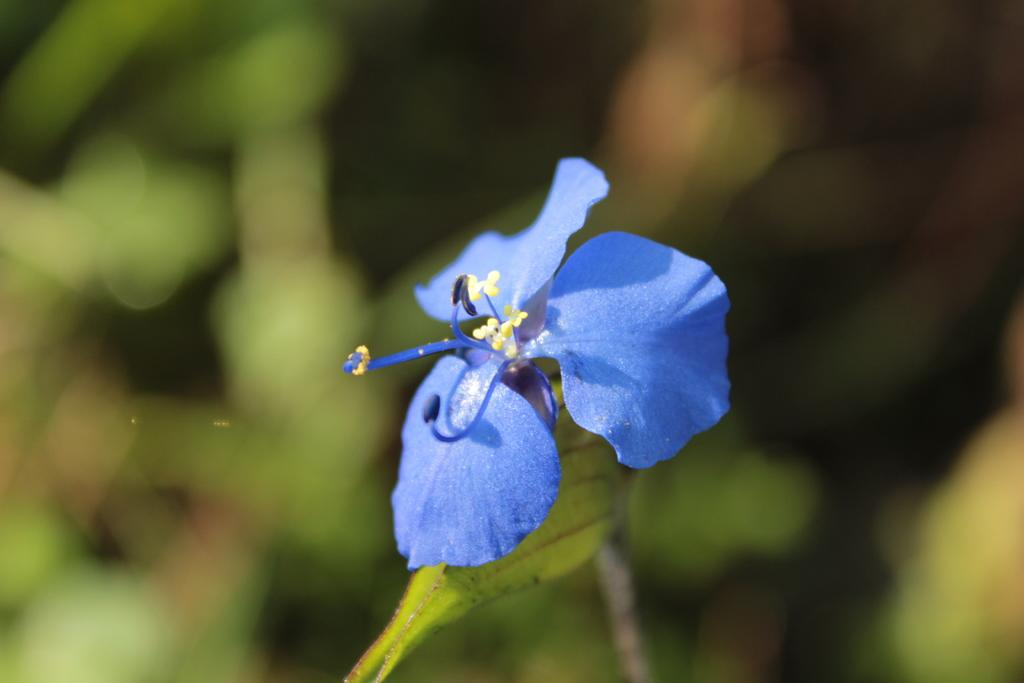What type of flower is in the picture? There is a blue flower in the picture. Can you describe the background of the picture? The background behind the flower is blurred. How many bikes are visible in the picture? There are no bikes present in the picture; it only features a blue flower with a blurred background. 